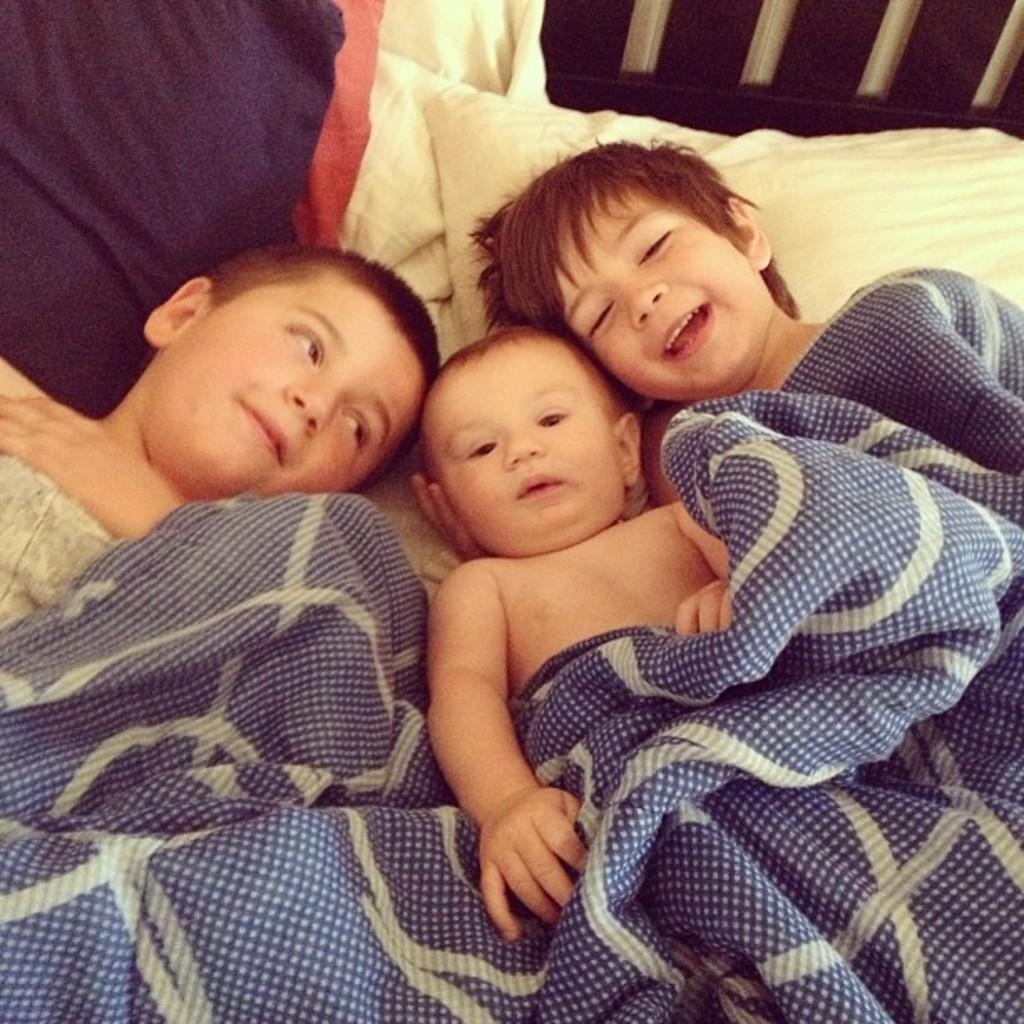What is the main subject of the image? The main subject of the image is a baby. Are there any other people in the image? Yes, there are two boys in the image. Where are the baby and the two boys located? The baby and the two boys are on a bed. What type of rifle is the baby holding in the image? There is no rifle present in the image; it features a baby and two boys on a bed. 